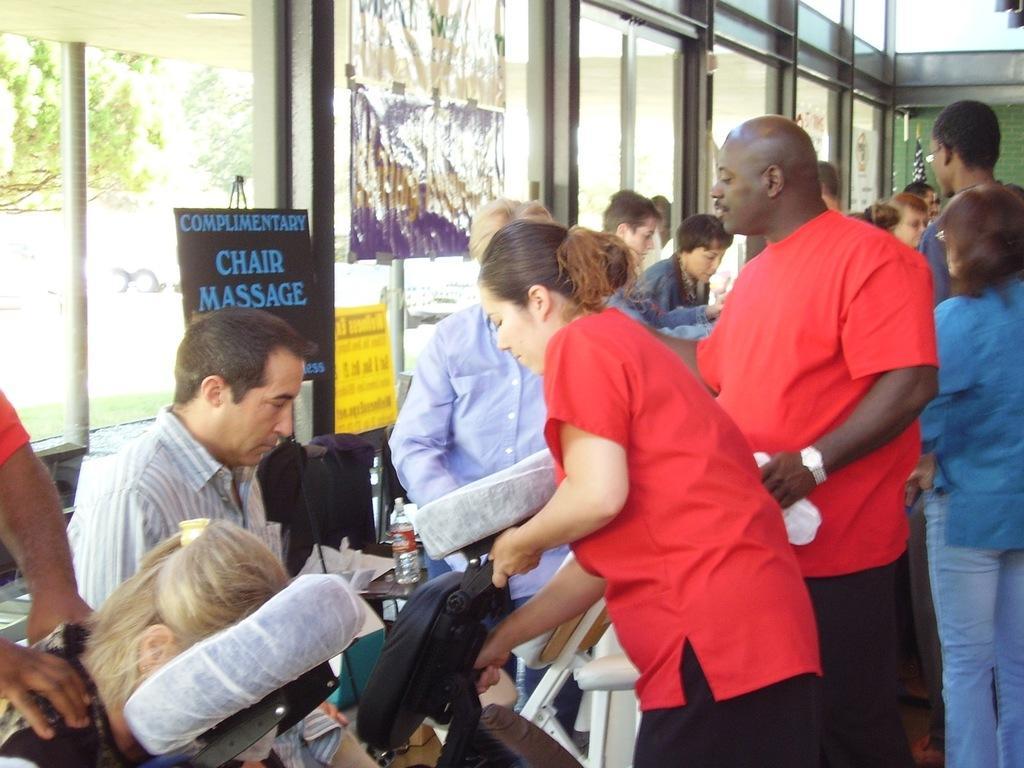Describe this image in one or two sentences. In the center of the image some persons are standing. In the middle of the image we can see a bag, bottle, glass, table, chair are present. In the background of the image we can see a tree, truck, signboard, glass, windows are present. 